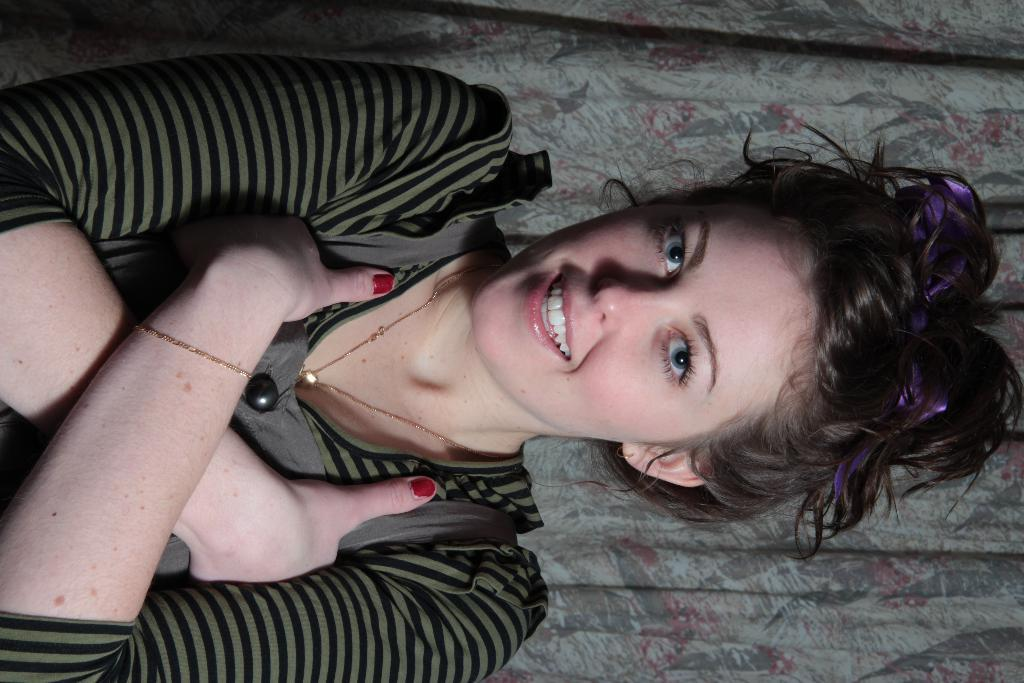Who is present in the image? There is a woman in the image. What is the woman's facial expression? The woman is smiling. What is the woman holding in the image? The woman is holding an object. What type of berry can be seen on the woman's wrist in the image? There is no berry present on the woman's wrist in the image. How many deer are visible in the image? There are no deer present in the image. 